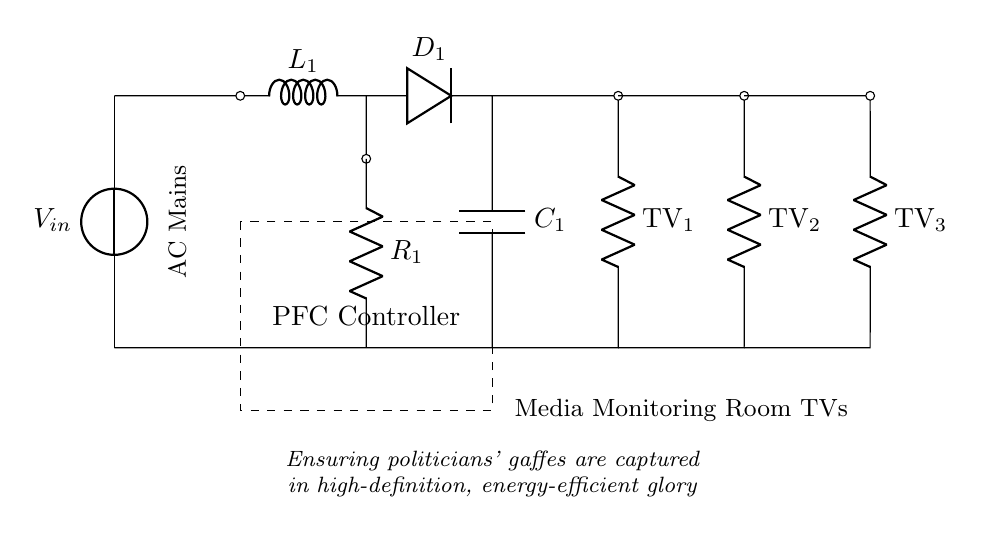What is the voltage source in this circuit? The voltage source is labeled as V_in at the top-left of the circuit diagram. It indicates the input voltage being supplied to the circuit.
Answer: V_in What type of component is labeled L1? The component labeled L1 is an inductor, as indicated by the symbol and label in the circuit diagram. Inductors are used in power factor correction circuits to improve reactive power.
Answer: Inductor How many televisions are connected as loads? The circuit diagram shows three separate resistors labeled TV_1, TV_2, and TV_3, indicating three televisions connected as loads in parallel to the output.
Answer: Three What function does the component D1 serve in this circuit? The component D1 is a diode, which allows current to flow in one direction and is used to rectify the AC current in the circuit for energy-efficient operation.
Answer: Diode What does the PFC controller do? The PFC controller, represented by the dashed rectangle, regulates the power factor correction process to optimize energy efficiency while accommodating the multiple television loads.
Answer: Regulates power factor How does the inductor L1 affect the circuit's performance? The inductor L1 contributes to the reactive power of the circuit, improving the power factor by reducing phase difference between voltage and current, hence optimizing efficiency in the operation of the televisions.
Answer: Improves power factor What is the purpose of including a resistor R1 in this circuit? The resistor R1 serves as a load in the circuit, representing additional resistance that can impact the overall power factor and provide a reference for the PFC controller's operations.
Answer: Represents load 